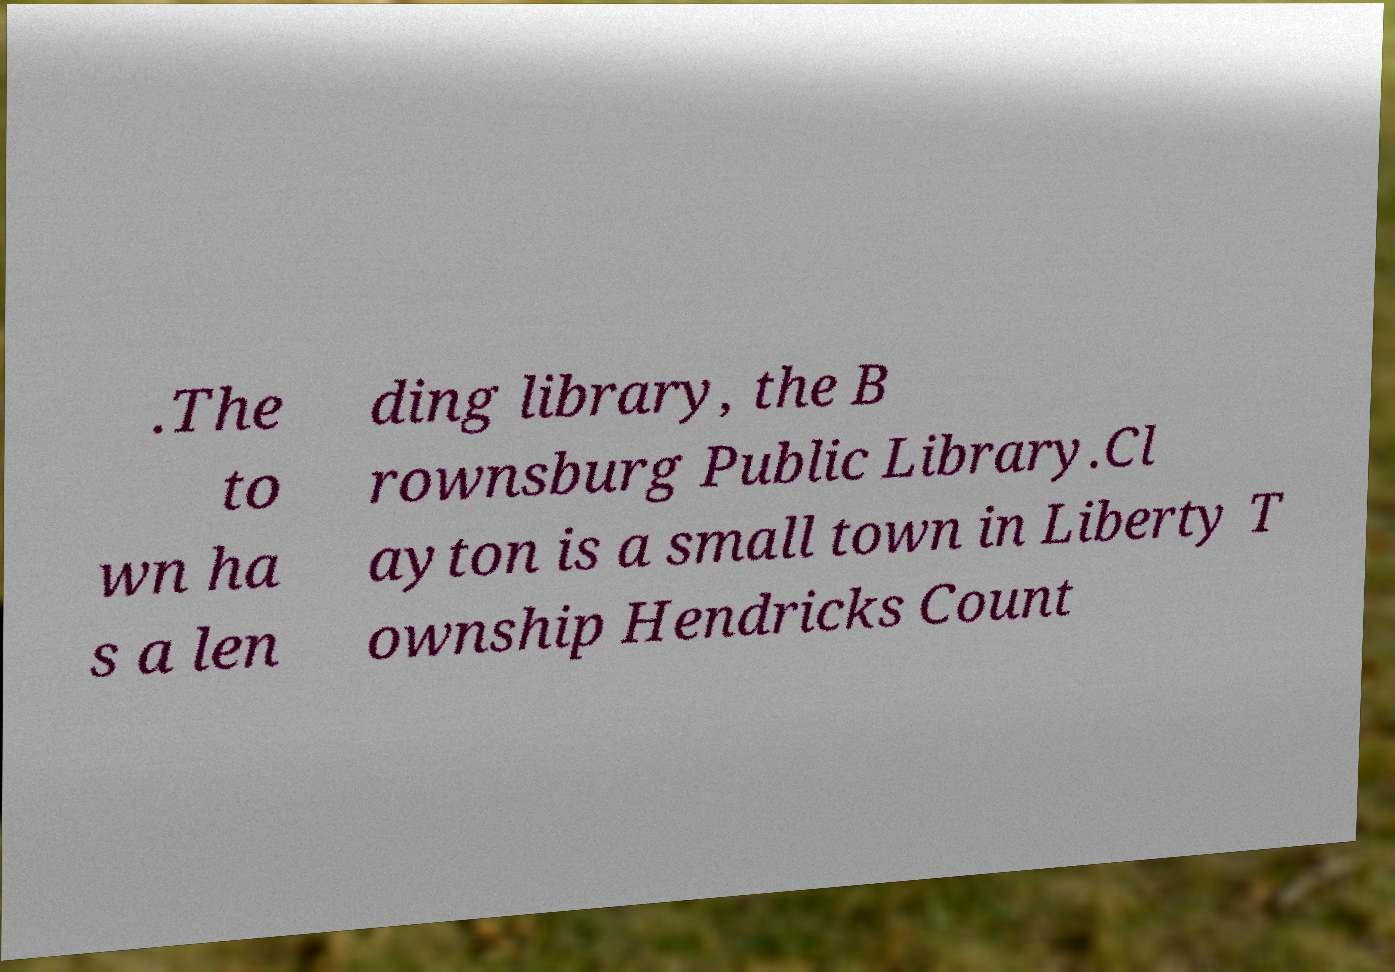What messages or text are displayed in this image? I need them in a readable, typed format. .The to wn ha s a len ding library, the B rownsburg Public Library.Cl ayton is a small town in Liberty T ownship Hendricks Count 